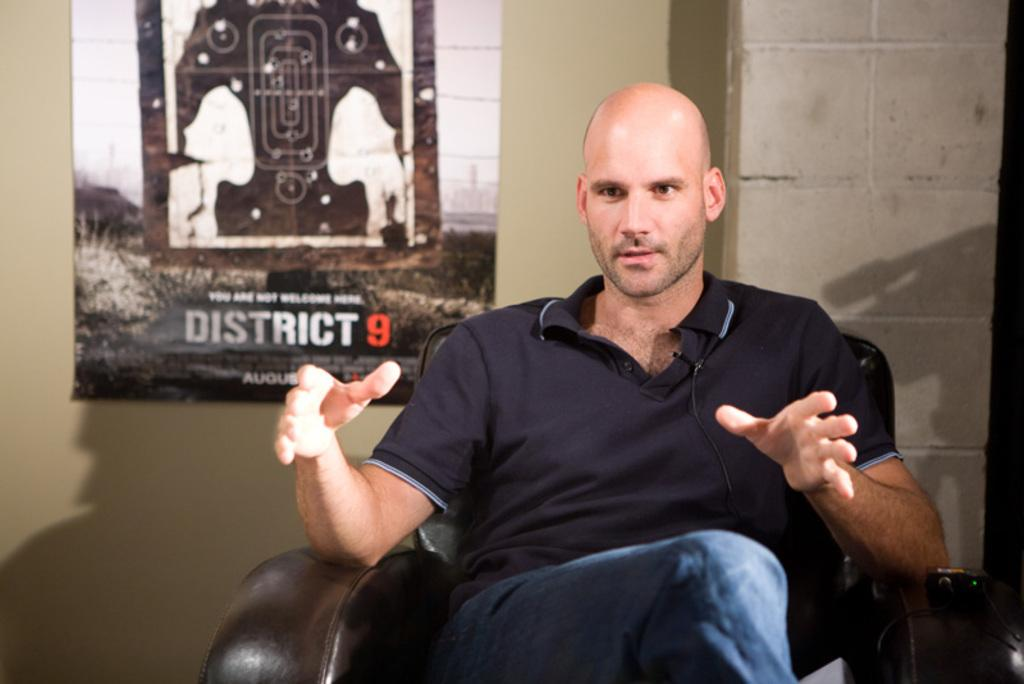Who is present in the image? There is a man in the image. What is the man doing in the image? The man is seated on a chair and speaking. What can be seen on the wall behind the man? There is a poster on the wall behind the man. What type of destruction can be seen happening in the image? There is no destruction present in the image; it features a man seated on a chair and speaking, with a poster on the wall behind him. 